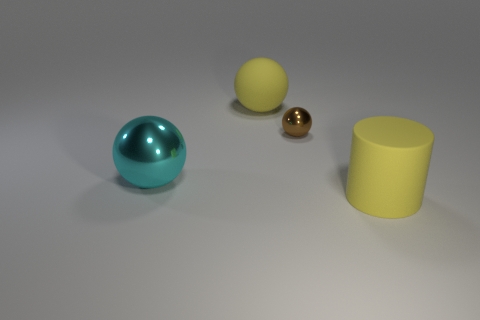How many things are the same color as the matte ball?
Keep it short and to the point. 1. There is a big object that is the same color as the cylinder; what material is it?
Give a very brief answer. Rubber. How many metal things are either brown spheres or spheres?
Your answer should be compact. 2. What is the size of the brown shiny sphere?
Ensure brevity in your answer.  Small. Is the cylinder the same size as the brown metal thing?
Give a very brief answer. No. There is a yellow thing that is in front of the small thing; what is it made of?
Your response must be concise. Rubber. What is the material of the other yellow thing that is the same shape as the tiny thing?
Give a very brief answer. Rubber. There is a large yellow object that is behind the cyan object; are there any big cyan things behind it?
Your answer should be compact. No. Does the big cyan metallic thing have the same shape as the brown thing?
Your answer should be very brief. Yes. What is the shape of the yellow object that is the same material as the yellow sphere?
Make the answer very short. Cylinder. 